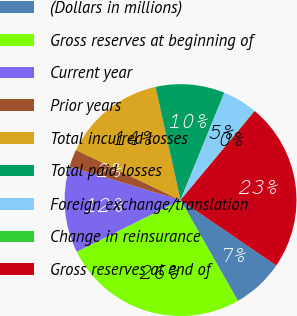Convert chart to OTSL. <chart><loc_0><loc_0><loc_500><loc_500><pie_chart><fcel>(Dollars in millions)<fcel>Gross reserves at beginning of<fcel>Current year<fcel>Prior years<fcel>Total incurred losses<fcel>Total paid losses<fcel>Foreign exchange/translation<fcel>Change in reinsurance<fcel>Gross reserves at end of<nl><fcel>7.23%<fcel>25.88%<fcel>12.03%<fcel>2.44%<fcel>14.42%<fcel>9.63%<fcel>4.84%<fcel>0.05%<fcel>23.48%<nl></chart> 